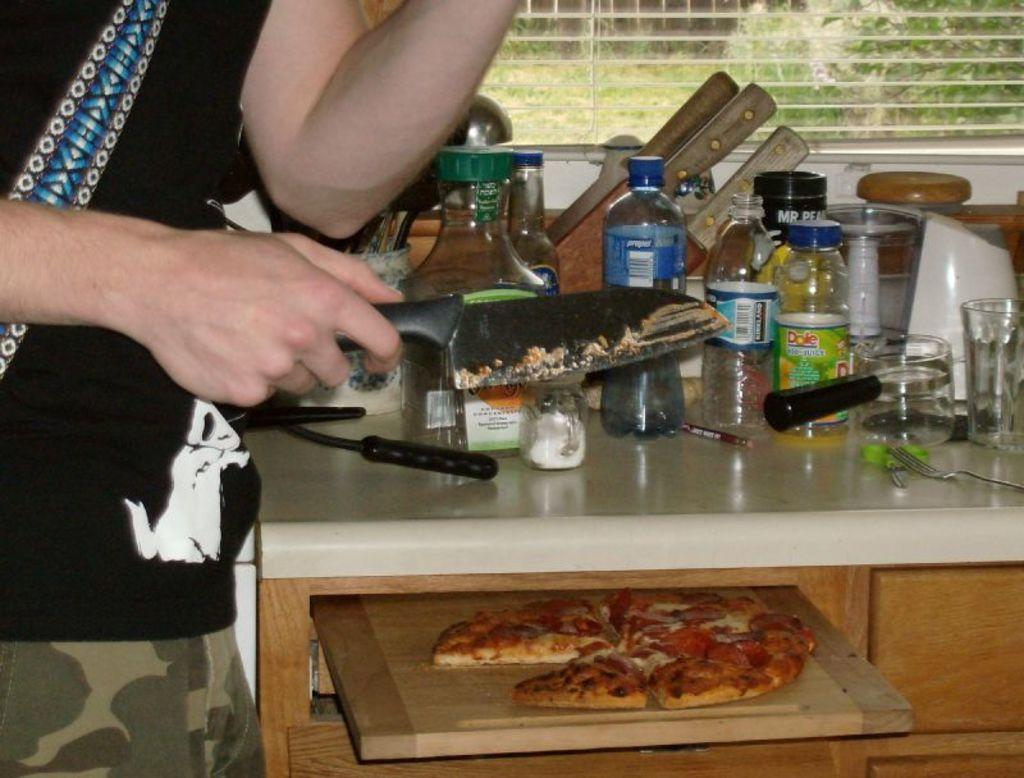What is the main subject of the image? There is a person in the image. What is the person holding in his hand? The person is holding a knife in his hand. What can be seen on the table in the image? There are various jars on the table. Can you describe what is below the table in the image? There is a pizza present below the table. How many jellyfish are visible in the image? There are no jellyfish present in the image. What type of group is the person interacting with in the image? The image does not show the person interacting with any group. 